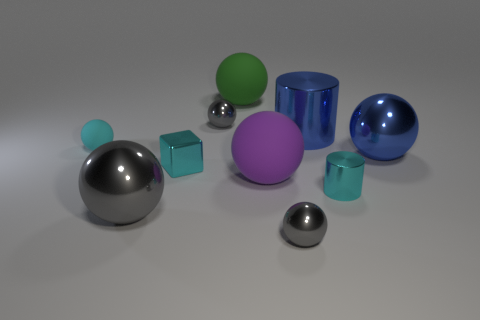Subtract all matte balls. How many balls are left? 4 Subtract 4 balls. How many balls are left? 3 Subtract all brown blocks. How many gray balls are left? 3 Subtract all gray balls. How many balls are left? 4 Subtract all balls. How many objects are left? 3 Add 8 big blue metallic objects. How many big blue metallic objects are left? 10 Add 5 small rubber spheres. How many small rubber spheres exist? 6 Subtract 0 brown cylinders. How many objects are left? 10 Subtract all red spheres. Subtract all gray cylinders. How many spheres are left? 7 Subtract all big shiny balls. Subtract all big spheres. How many objects are left? 4 